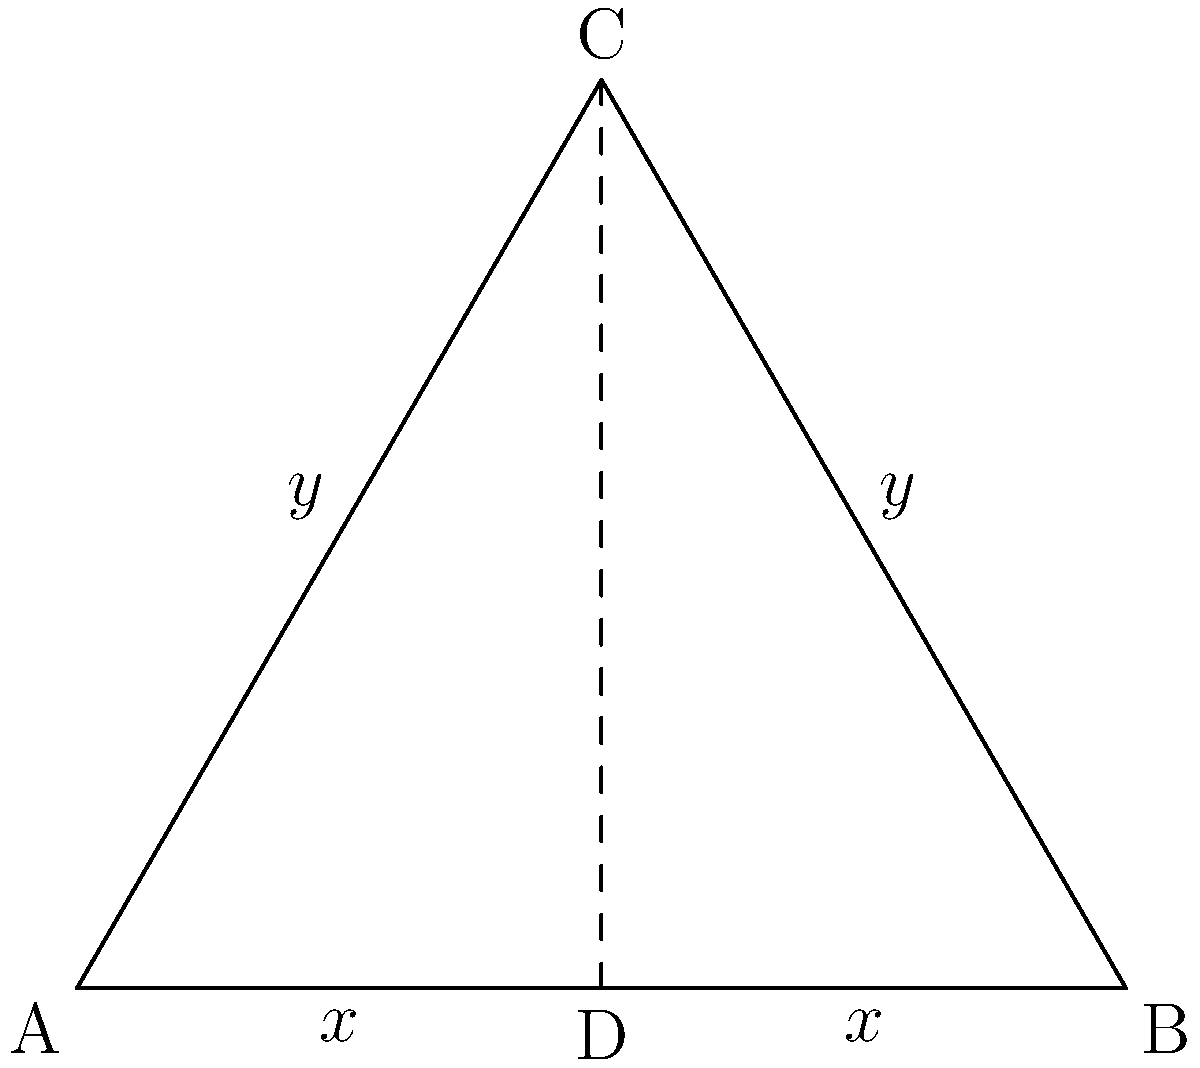In a responsive web layout, you're designing a triangular element that needs to maintain its shape across different screen sizes. The triangle ABC is isosceles, with AB as the base. Point D is the midpoint of AB. If the width of the triangle (AB) is represented by $2x$ and the height (CD) is $y$, what is the relationship between $x$ and $y$ to ensure the triangle remains congruent when resized? To solve this problem, let's follow these steps:

1. Recognize that triangle ABC is isosceles, with AC = BC.

2. Since D is the midpoint of AB, AD = DB = $x$.

3. Triangle ACD is a right triangle (CD is perpendicular to AB in an isosceles triangle).

4. In triangle ACD, we can use the Pythagorean theorem:
   $AC^2 = AD^2 + CD^2$

5. We know that $AD = x$ and $CD = y$, so:
   $AC^2 = x^2 + y^2$

6. In an equilateral triangle, the relationship between the side length ($s$) and height ($h$) is:
   $h = \frac{\sqrt{3}}{2}s$

7. In our isosceles triangle, $AC$ is the side length, and $y$ is the height. So:
   $y = \frac{\sqrt{3}}{2}AC$

8. Squaring both sides:
   $y^2 = \frac{3}{4}AC^2$

9. Substituting the result from step 5:
   $y^2 = \frac{3}{4}(x^2 + y^2)$

10. Simplifying:
    $4y^2 = 3x^2 + 3y^2$
    $y^2 = 3x^2$

11. Taking the square root of both sides:
    $y = x\sqrt{3}$

This relationship ensures that the triangle remains congruent when resized, maintaining its 30-60-90 proportions in a responsive layout.
Answer: $y = x\sqrt{3}$ 